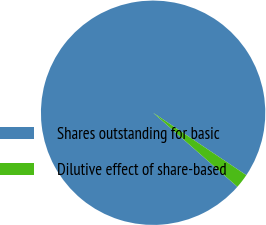<chart> <loc_0><loc_0><loc_500><loc_500><pie_chart><fcel>Shares outstanding for basic<fcel>Dilutive effect of share-based<nl><fcel>97.92%<fcel>2.08%<nl></chart> 